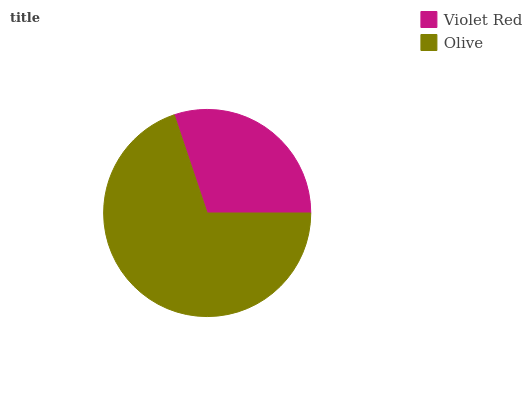Is Violet Red the minimum?
Answer yes or no. Yes. Is Olive the maximum?
Answer yes or no. Yes. Is Olive the minimum?
Answer yes or no. No. Is Olive greater than Violet Red?
Answer yes or no. Yes. Is Violet Red less than Olive?
Answer yes or no. Yes. Is Violet Red greater than Olive?
Answer yes or no. No. Is Olive less than Violet Red?
Answer yes or no. No. Is Olive the high median?
Answer yes or no. Yes. Is Violet Red the low median?
Answer yes or no. Yes. Is Violet Red the high median?
Answer yes or no. No. Is Olive the low median?
Answer yes or no. No. 